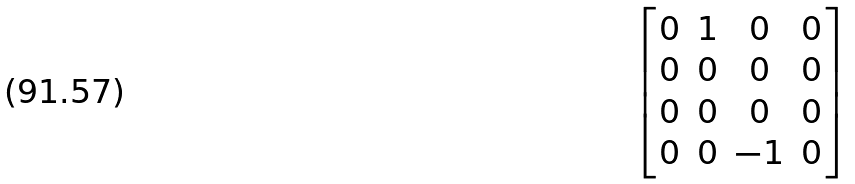<formula> <loc_0><loc_0><loc_500><loc_500>\begin{bmatrix} 0 & 1 & 0 & 0 \\ 0 & 0 & 0 & 0 \\ 0 & 0 & 0 & 0 \\ 0 & 0 & - 1 & 0 \end{bmatrix}</formula> 